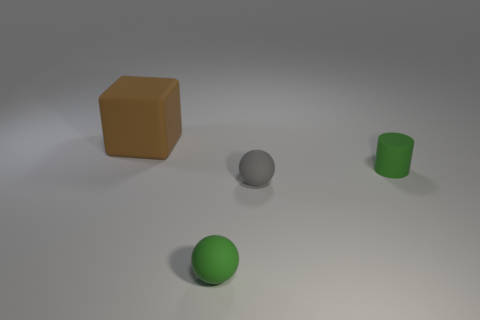How many cyan objects are either large objects or matte objects?
Your answer should be compact. 0. There is a small green object on the right side of the tiny ball on the right side of the small green matte thing that is in front of the green matte cylinder; what shape is it?
Keep it short and to the point. Cylinder. There is a rubber ball that is the same size as the gray thing; what color is it?
Provide a succinct answer. Green. What number of other objects are the same shape as the large matte thing?
Provide a succinct answer. 0. There is a green rubber cylinder; does it have the same size as the block on the left side of the gray sphere?
Give a very brief answer. No. What shape is the green rubber thing that is to the right of the tiny green thing on the left side of the gray ball?
Offer a terse response. Cylinder. Is the number of gray rubber things right of the cylinder less than the number of cylinders?
Your answer should be very brief. Yes. The small matte thing that is the same color as the small cylinder is what shape?
Provide a short and direct response. Sphere. How many gray blocks are the same size as the green rubber sphere?
Provide a succinct answer. 0. What shape is the small green matte thing in front of the tiny green cylinder?
Your response must be concise. Sphere. 